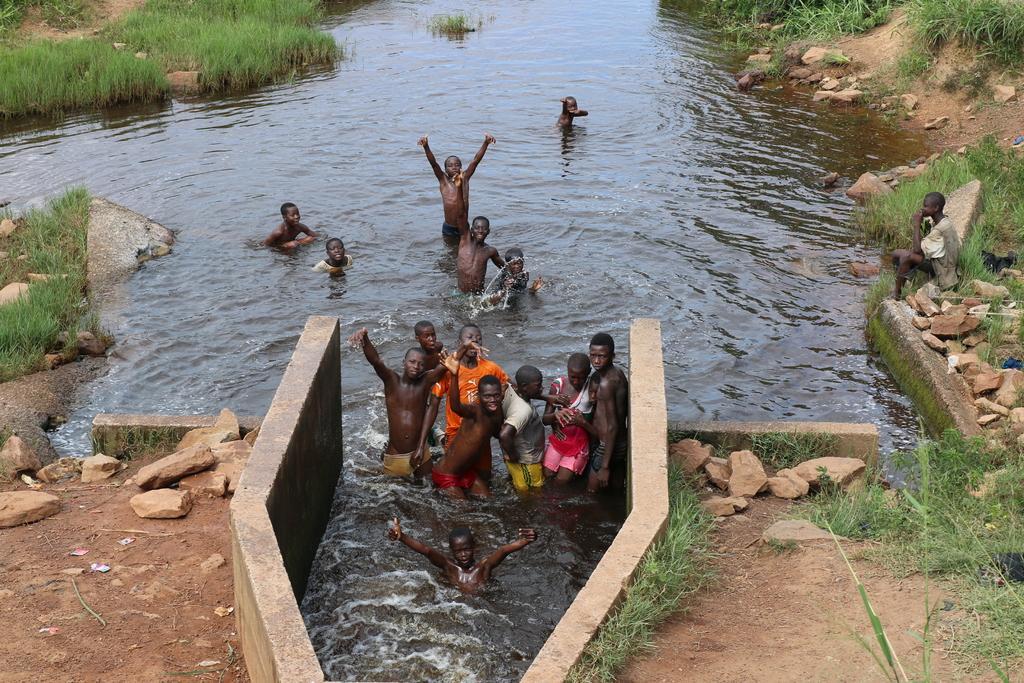Please provide a concise description of this image. In the picture we can see a canal with water and some people are bathing in it and beside it, we can see some wall construction and some part of water in it and some people are standing and near the canal we can see some mud surface with rocks, and grass and in the background also we can see some grass surface and rocks. 